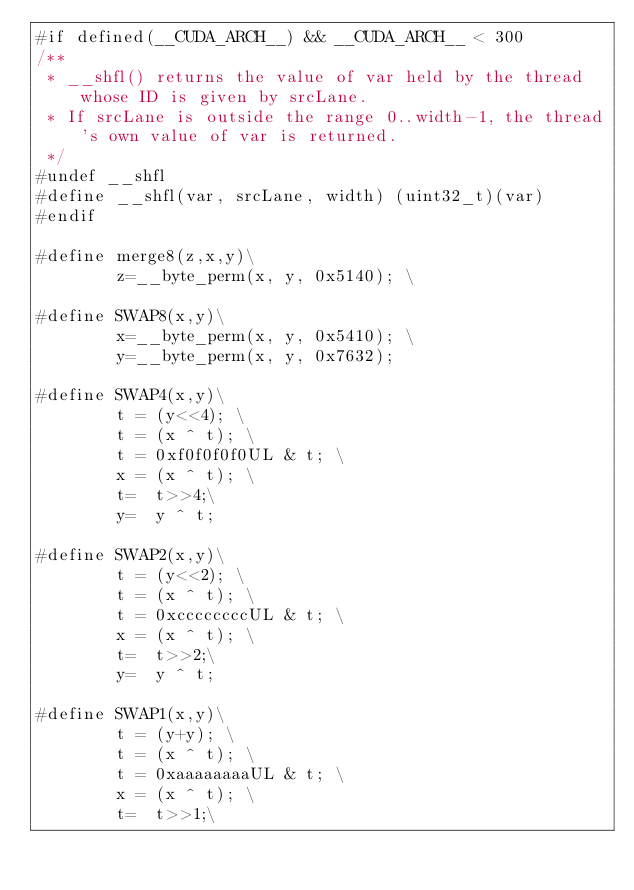Convert code to text. <code><loc_0><loc_0><loc_500><loc_500><_Cuda_>#if defined(__CUDA_ARCH__) && __CUDA_ARCH__ < 300
/**
 * __shfl() returns the value of var held by the thread whose ID is given by srcLane.
 * If srcLane is outside the range 0..width-1, the thread's own value of var is returned.
 */
#undef __shfl
#define __shfl(var, srcLane, width) (uint32_t)(var)
#endif

#define merge8(z,x,y)\
		z=__byte_perm(x, y, 0x5140); \

#define SWAP8(x,y)\
		x=__byte_perm(x, y, 0x5410); \
		y=__byte_perm(x, y, 0x7632);

#define SWAP4(x,y)\
		t = (y<<4); \
		t = (x ^ t); \
		t = 0xf0f0f0f0UL & t; \
		x = (x ^ t); \
		t=  t>>4;\
		y=  y ^ t;

#define SWAP2(x,y)\
		t = (y<<2); \
		t = (x ^ t); \
		t = 0xccccccccUL & t; \
		x = (x ^ t); \
		t=  t>>2;\
		y=  y ^ t;

#define SWAP1(x,y)\
		t = (y+y); \
		t = (x ^ t); \
		t = 0xaaaaaaaaUL & t; \
		x = (x ^ t); \
		t=  t>>1;\</code> 